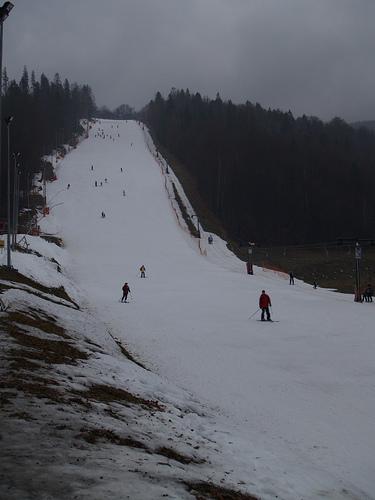What does the trail in the snow indicate?
Be succinct. Skiers. Is the snow piled up?
Answer briefly. Yes. What is laying on the ground?
Quick response, please. Snow. What activity are these people engaged in?
Be succinct. Skiing. Is this an inland location?
Give a very brief answer. Yes. How many snowboarders are shown?
Short answer required. 0. Is this picture uphill or downhill?
Concise answer only. Uphill. Is it daytime?
Keep it brief. Yes. What season is it?
Answer briefly. Winter. 